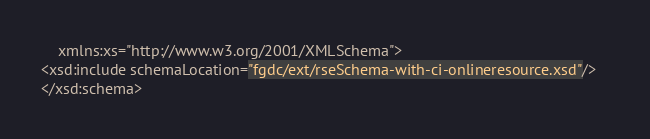Convert code to text. <code><loc_0><loc_0><loc_500><loc_500><_XML_>    xmlns:xs="http://www.w3.org/2001/XMLSchema">
<xsd:include schemaLocation="fgdc/ext/rseSchema-with-ci-onlineresource.xsd"/>   
</xsd:schema>


</code> 